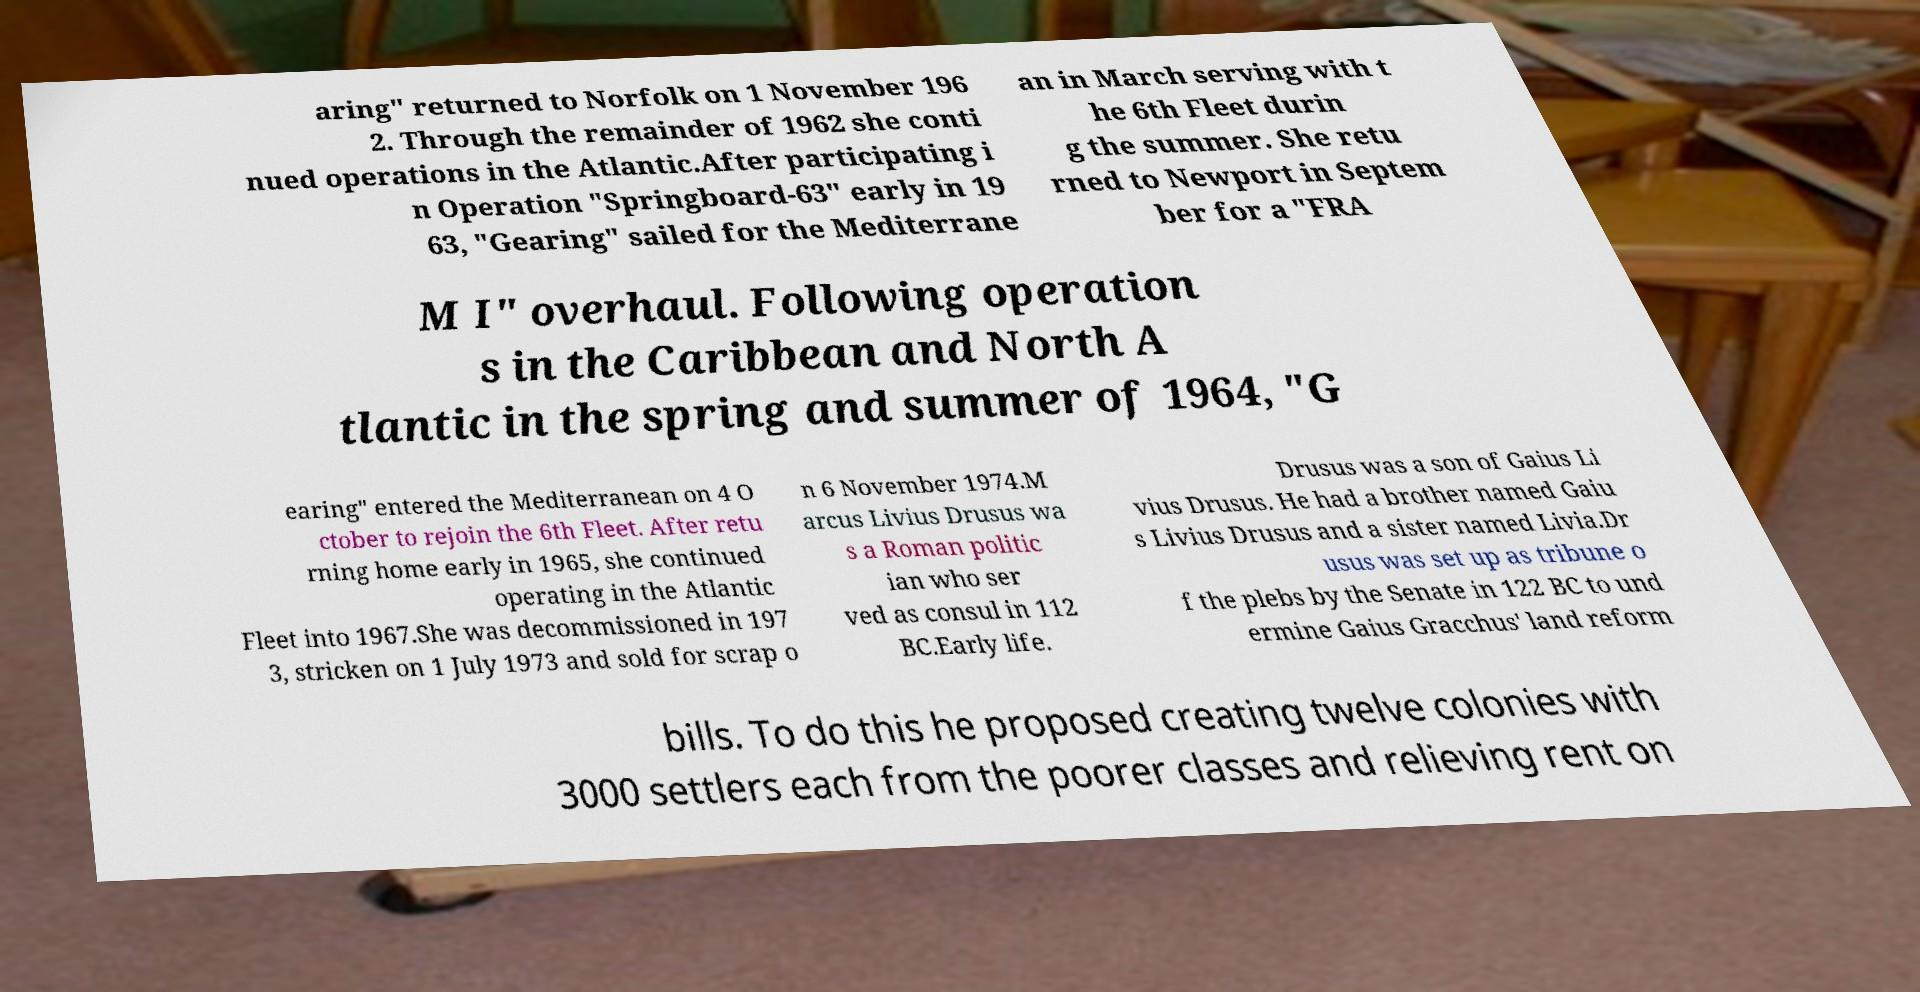What messages or text are displayed in this image? I need them in a readable, typed format. aring" returned to Norfolk on 1 November 196 2. Through the remainder of 1962 she conti nued operations in the Atlantic.After participating i n Operation "Springboard-63" early in 19 63, "Gearing" sailed for the Mediterrane an in March serving with t he 6th Fleet durin g the summer. She retu rned to Newport in Septem ber for a "FRA M I" overhaul. Following operation s in the Caribbean and North A tlantic in the spring and summer of 1964, "G earing" entered the Mediterranean on 4 O ctober to rejoin the 6th Fleet. After retu rning home early in 1965, she continued operating in the Atlantic Fleet into 1967.She was decommissioned in 197 3, stricken on 1 July 1973 and sold for scrap o n 6 November 1974.M arcus Livius Drusus wa s a Roman politic ian who ser ved as consul in 112 BC.Early life. Drusus was a son of Gaius Li vius Drusus. He had a brother named Gaiu s Livius Drusus and a sister named Livia.Dr usus was set up as tribune o f the plebs by the Senate in 122 BC to und ermine Gaius Gracchus' land reform bills. To do this he proposed creating twelve colonies with 3000 settlers each from the poorer classes and relieving rent on 